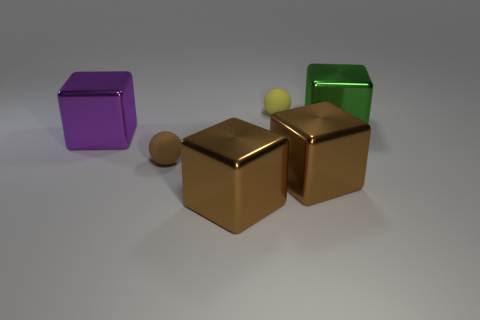Subtract all green cubes. How many cubes are left? 3 Add 1 large green objects. How many objects exist? 7 Subtract all brown cubes. How many cubes are left? 2 Subtract all blocks. How many objects are left? 2 Subtract 1 balls. How many balls are left? 1 Subtract all yellow blocks. Subtract all purple spheres. How many blocks are left? 4 Subtract all gray cylinders. How many cyan blocks are left? 0 Subtract all tiny spheres. Subtract all big yellow matte objects. How many objects are left? 4 Add 3 large brown blocks. How many large brown blocks are left? 5 Add 4 tiny gray metal things. How many tiny gray metal things exist? 4 